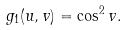Convert formula to latex. <formula><loc_0><loc_0><loc_500><loc_500>g _ { 1 } ( u , v ) = \cos ^ { 2 } v .</formula> 